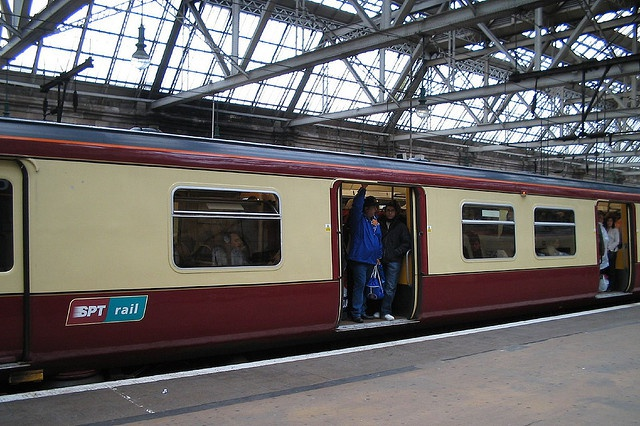Describe the objects in this image and their specific colors. I can see train in gray, black, tan, maroon, and darkgray tones, people in gray, black, navy, and darkblue tones, people in gray, black, navy, and maroon tones, people in gray and black tones, and people in gray, black, and maroon tones in this image. 